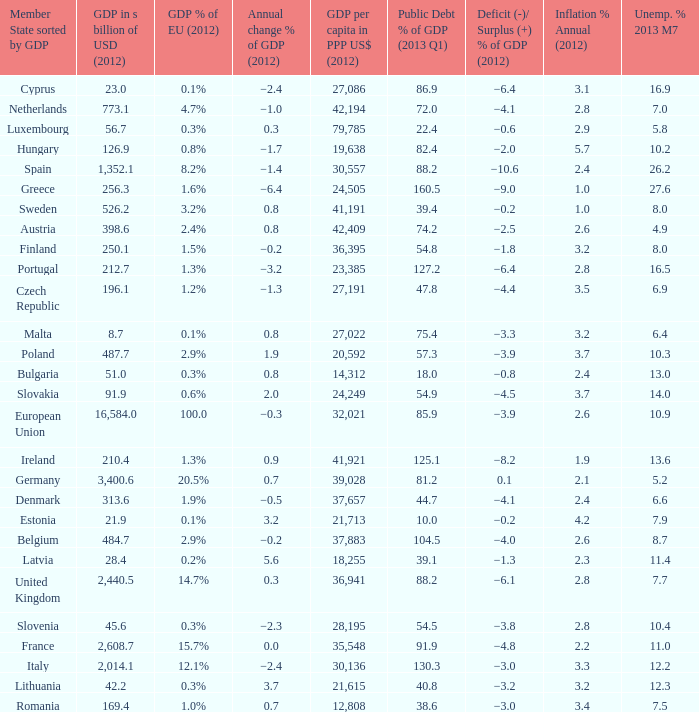What is the deficit/surplus % of the 2012 GDP of the country with a GDP in billions of USD in 2012 less than 1,352.1, a GDP per capita in PPP US dollars in 2012 greater than 21,615, public debt % of GDP in the 2013 Q1 less than 75.4, and an inflation % annual in 2012 of 2.9? −0.6. 